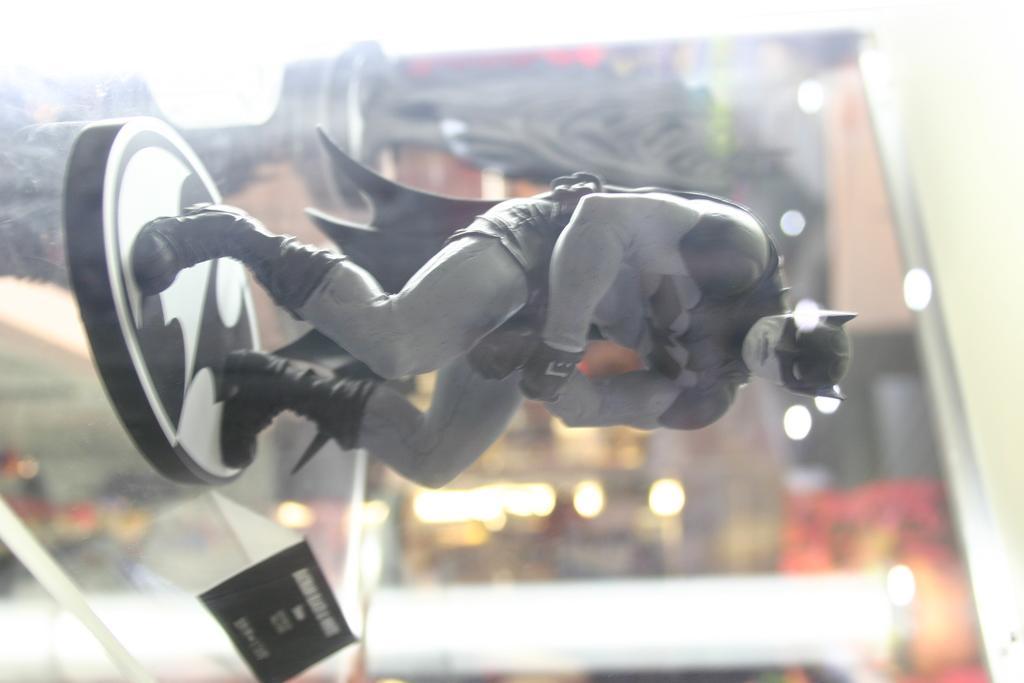Please provide a concise description of this image. In this image I can see a toy batman which is in ash and black color. It is on the glass rack. We can see black color board. Background is blurred. 